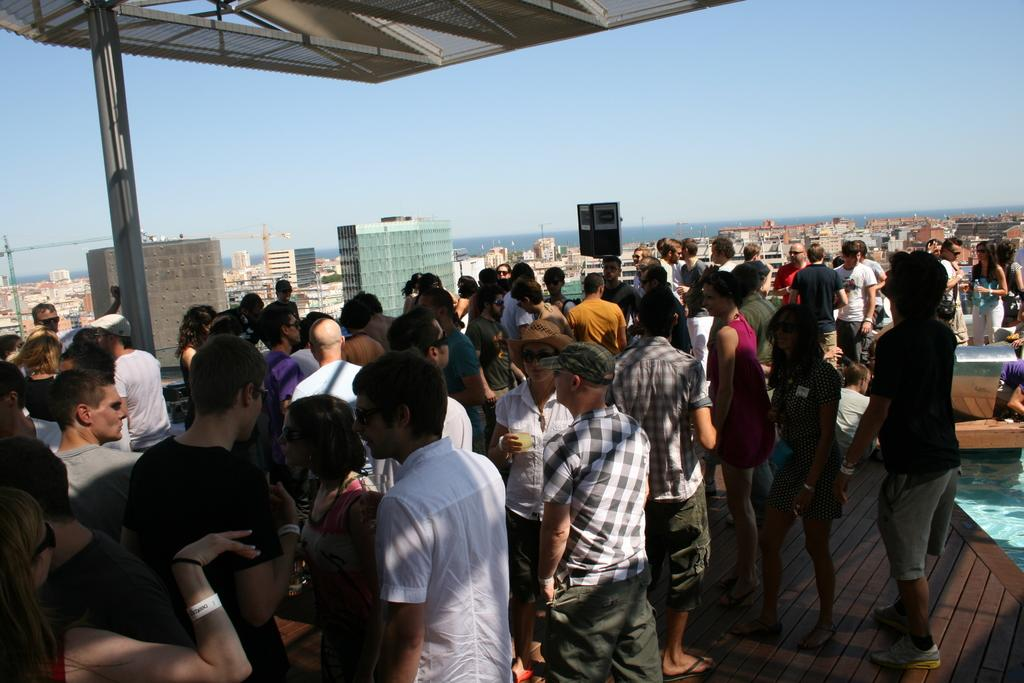What type of event is taking place in the image? There is a beach party in the image. Where is the crowd gathered in the image? The crowd is gathered at the sea port. What can be seen behind the crowd? There are buildings visible behind the crowd. What type of large vehicles are present in the image? There are big ships in the image. What type of calculator is being used by the sister in the image? There is no sister or calculator present in the image. 